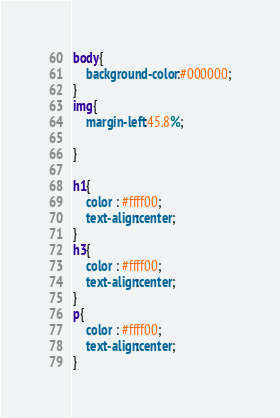Convert code to text. <code><loc_0><loc_0><loc_500><loc_500><_CSS_>body{
	background-color:#000000;
}
img{
	margin-left:45.8%;
	
}

h1{
	color : #ffff00;
	text-align:center;
}
h3{
	color : #ffff00;
	text-align:center;
}
p{
	color : #ffff00;
	text-align:center;
}</code> 